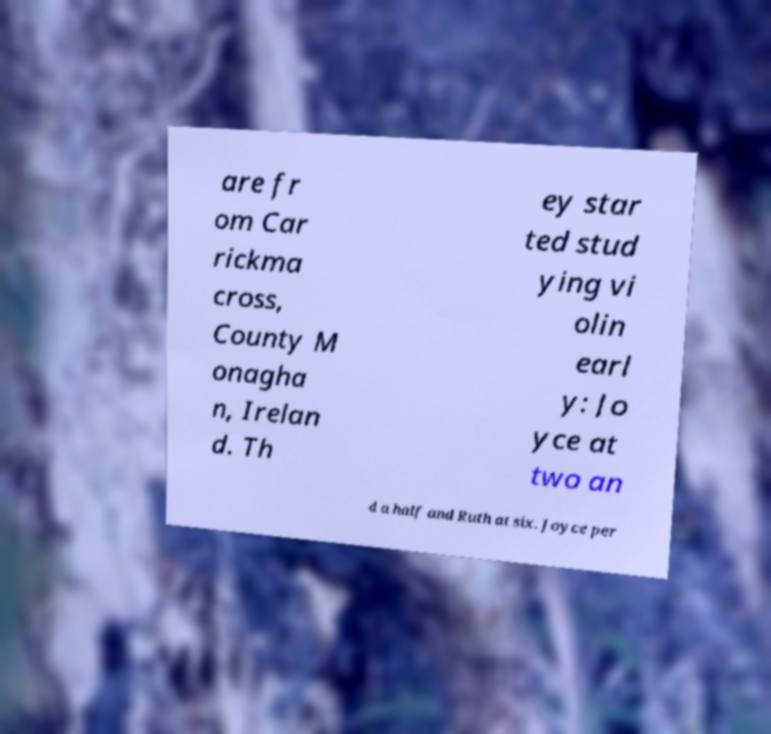Can you accurately transcribe the text from the provided image for me? are fr om Car rickma cross, County M onagha n, Irelan d. Th ey star ted stud ying vi olin earl y: Jo yce at two an d a half and Ruth at six. Joyce per 